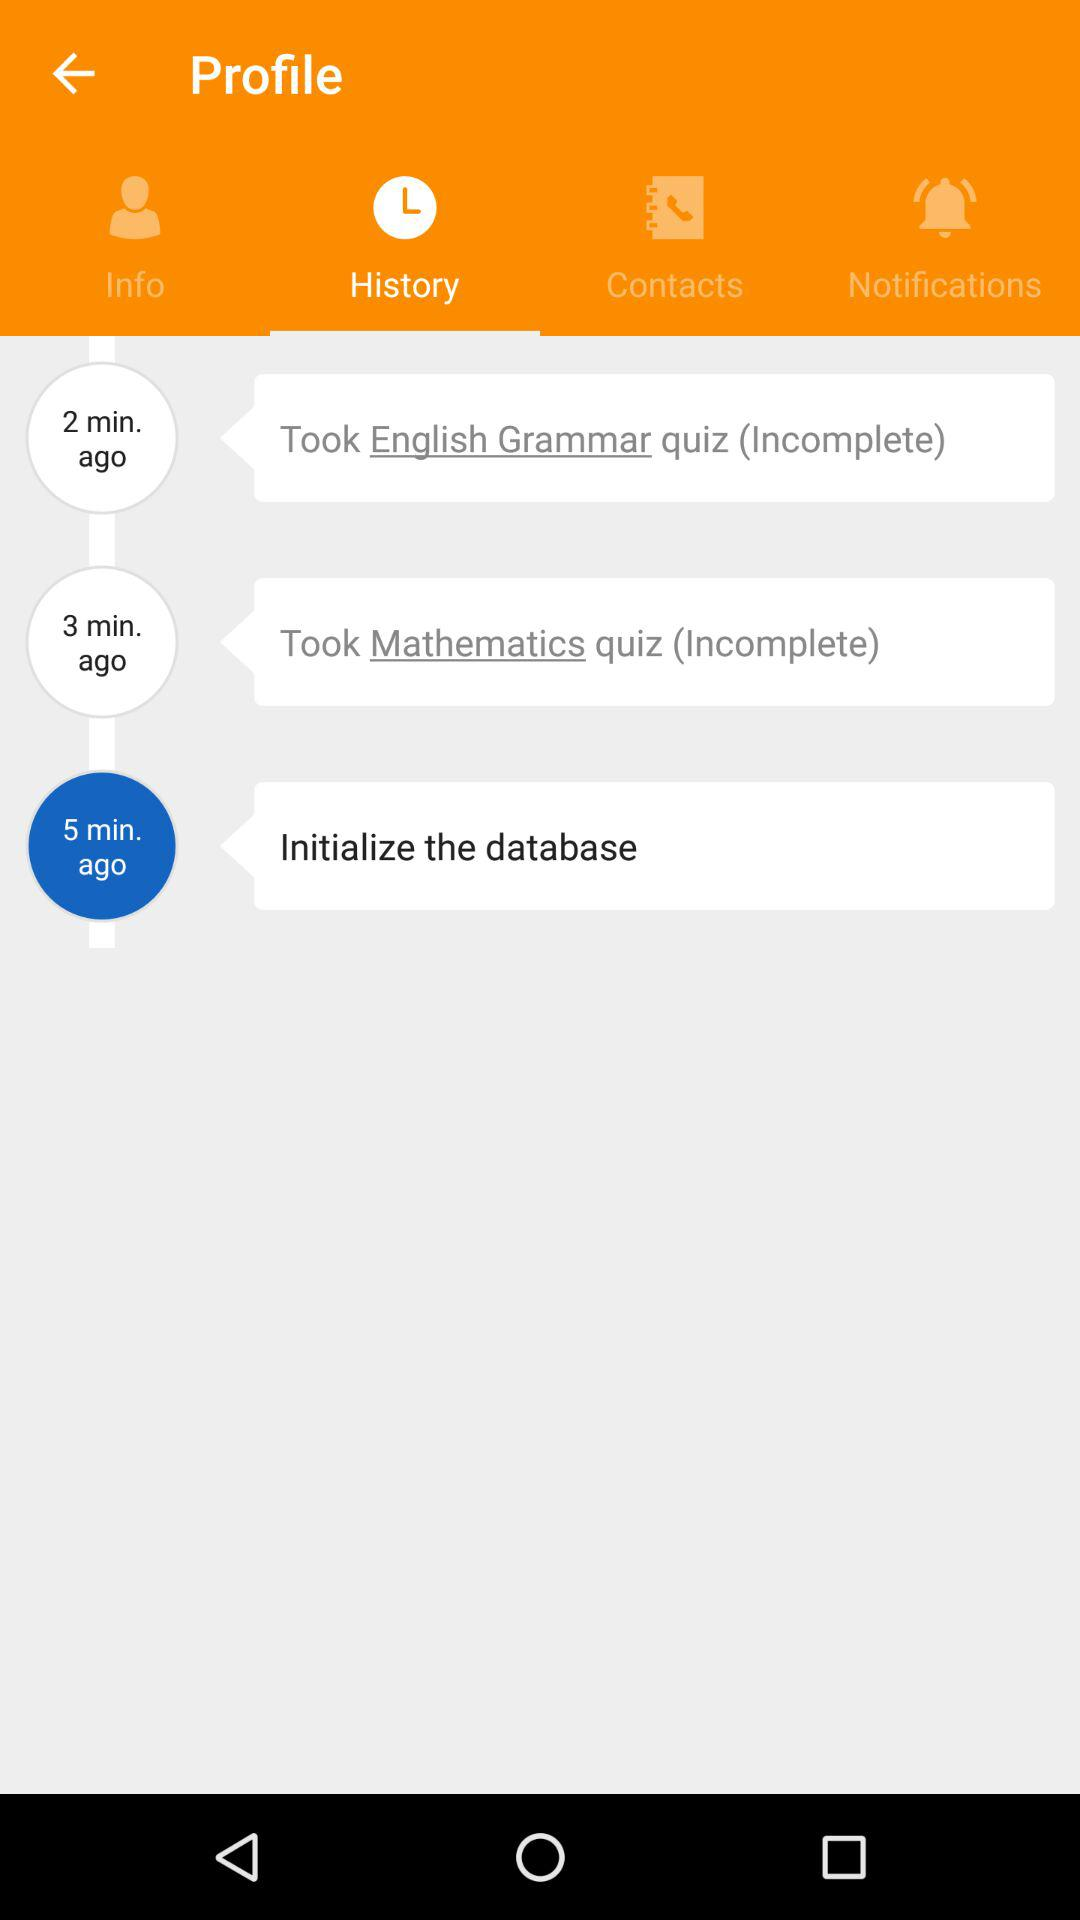How long ago was the "English grammar" quiz taken? The "English grammar" quiz was taken 2 minutes ago. 